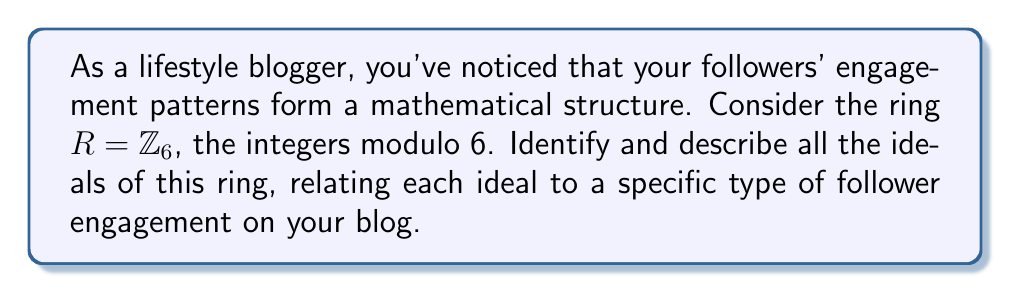Can you solve this math problem? To identify and describe the ideals of $R = \mathbb{Z}_6$, we need to follow these steps:

1) First, recall that an ideal $I$ of a ring $R$ is a subset of $R$ that satisfies three properties:
   a) $I$ is closed under addition
   b) For any $r \in R$ and $i \in I$, both $ri$ and $ir$ are in $I$
   c) $I$ is non-empty

2) In $\mathbb{Z}_6$, we have elements $\{0, 1, 2, 3, 4, 5\}$.

3) Let's start with the trivial ideals:
   - $\{0\}$ is always an ideal (the zero ideal)
   - $\mathbb{Z}_6$ itself is always an ideal (the improper ideal)

4) Now, let's consider the principal ideals generated by each element:
   - $\langle 0 \rangle = \{0\}$
   - $\langle 1 \rangle = \{0, 1, 2, 3, 4, 5\} = \mathbb{Z}_6$
   - $\langle 2 \rangle = \{0, 2, 4\}$
   - $\langle 3 \rangle = \{0, 3\}$
   - $\langle 4 \rangle = \{0, 2, 4\}$
   - $\langle 5 \rangle = \{0, 1, 2, 3, 4, 5\} = \mathbb{Z}_6$

5) We can see that some of these ideals are identical. The distinct ideals are:
   - $\{0\}$
   - $\{0, 2, 4\}$
   - $\{0, 3\}$
   - $\mathbb{Z}_6$

Relating these to follower engagement:
- $\{0\}$: No engagement (lurkers)
- $\{0, 2, 4\}$: Moderate engagement (likes and shares)
- $\{0, 3\}$: Occasional engagement (comments)
- $\mathbb{Z}_6$: Full engagement (all types of interaction)
Answer: The ideals of $\mathbb{Z}_6$ are:
1) $\{0\}$ (zero ideal)
2) $\{0, 2, 4\}$
3) $\{0, 3\}$
4) $\mathbb{Z}_6$ (improper ideal) 